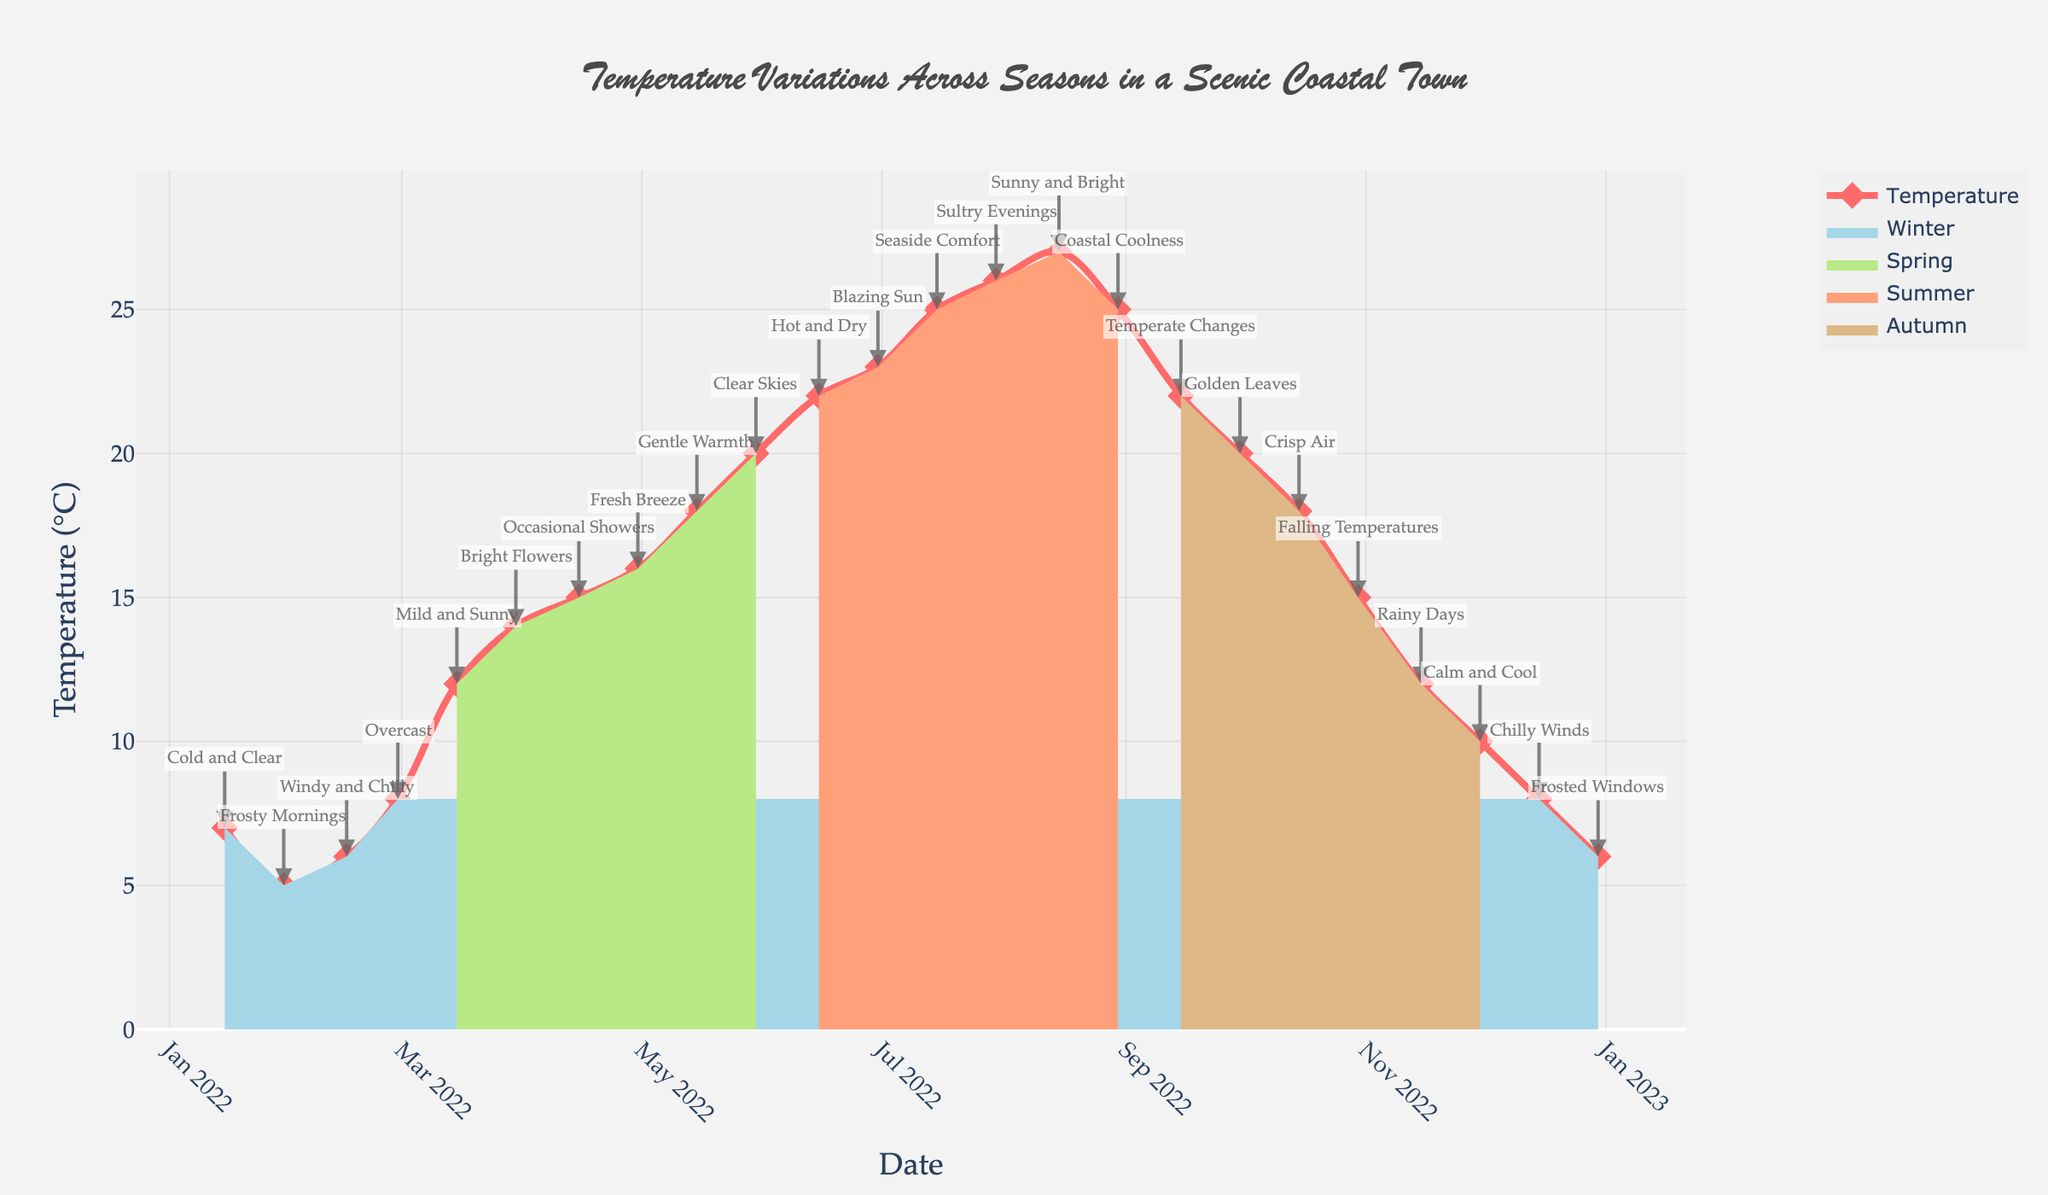How does the temperature trend change between Winter and Spring? To determine the temperature trend change between Winter and Spring, observe the temperatures during Winter (January and February) and compare them with the temperatures in Spring (March to May). In Winter, temperatures range from 5°C to 8°C and show a slight increase. In Spring, temperatures consistently rise from 12°C to 20°C. The trend clearly changes from a slight increase in Winter to a significant rise in Spring.
Answer: Significant rise in Spring What is the temperature on the hottest recorded day? Identify the highest temperature value in the plot and check the corresponding date. The hottest recorded day has a temperature of 27°C, which occurs on August 15th.
Answer: 27°C Which season shows the largest range of temperature variability? To find the season with the largest range of variability, compare the difference between the highest and lowest temperatures within each season. For Winter, the range is 8°C - 5°C = 3°C; for Spring, 20°C - 12°C = 8°C; for Summer, 27°C - 22°C = 5°C; for Autumn, 22°C - 10°C = 12°C. Autumn shows the largest range of variability.
Answer: Autumn How many data points represent Summer temperatures? Count the number of data points that correspond to the Summer season. There are data points on June 15, June 30, July 15, July 30, August 15, and August 30, totaling 6 data points.
Answer: 6 What general temperature pattern is observed during Autumn? To observe the general temperature pattern during Autumn, note the temperatures from September to November. Starting from 22°C in September, the temperature gradually decreases through October and November, reaching 10°C by the end of November. The general pattern is a steady decline.
Answer: Steady decline 